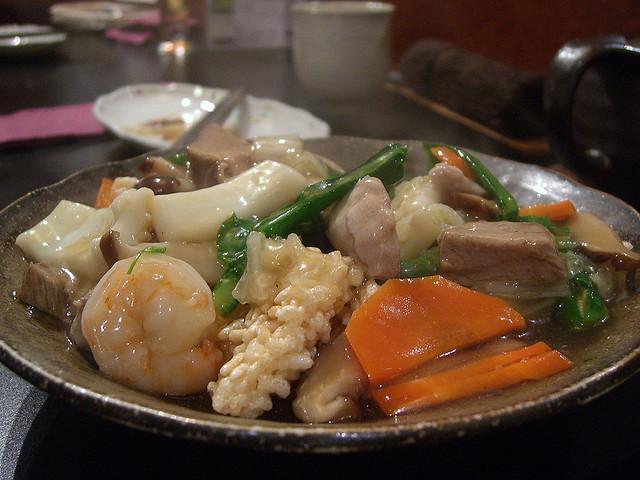How many shrimp can you see on the plate?
Give a very brief answer. 1. How many carrots are in the picture?
Give a very brief answer. 3. How many broccolis can you see?
Give a very brief answer. 2. How many people are standing on the ground in the image?
Give a very brief answer. 0. 